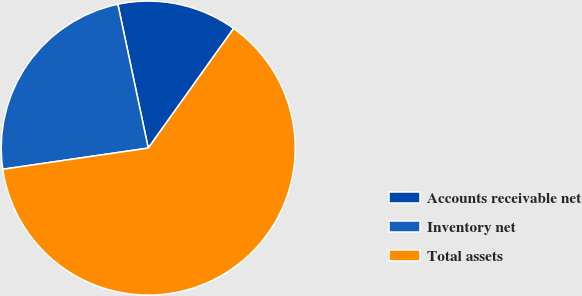Convert chart. <chart><loc_0><loc_0><loc_500><loc_500><pie_chart><fcel>Accounts receivable net<fcel>Inventory net<fcel>Total assets<nl><fcel>13.18%<fcel>23.99%<fcel>62.83%<nl></chart> 